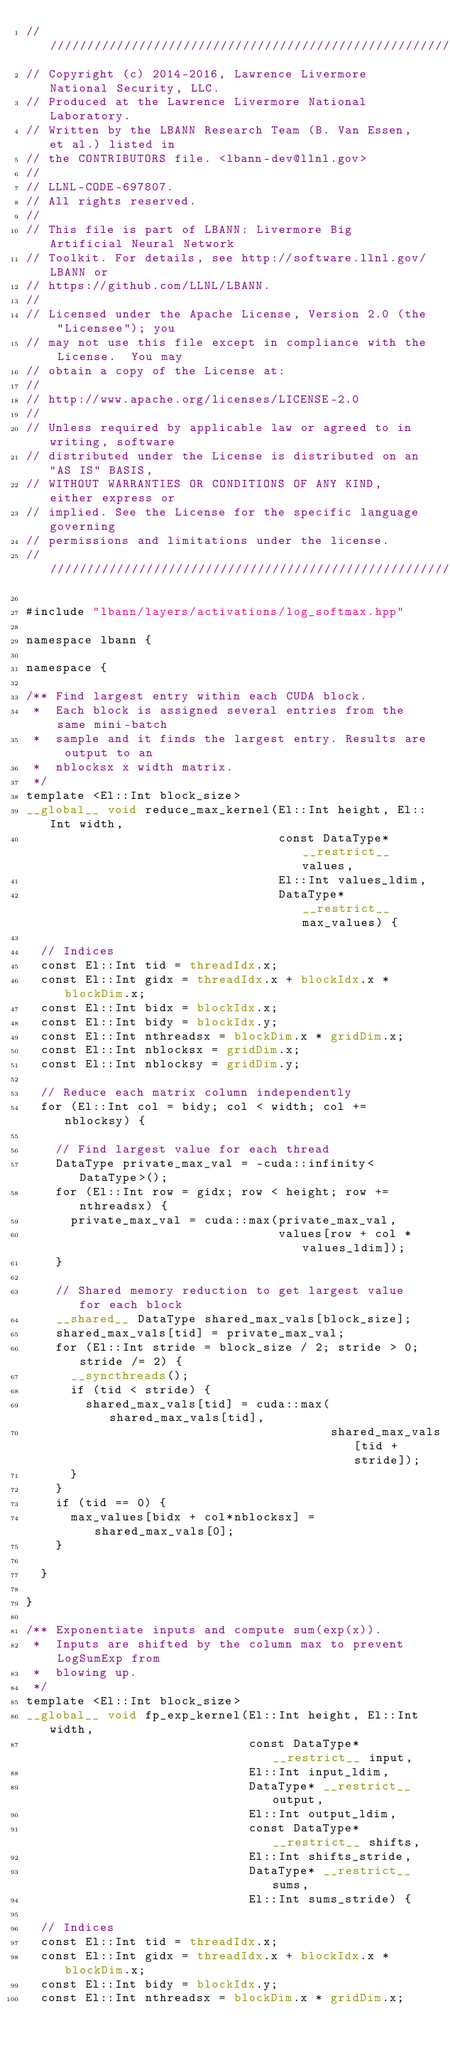<code> <loc_0><loc_0><loc_500><loc_500><_Cuda_>////////////////////////////////////////////////////////////////////////////////
// Copyright (c) 2014-2016, Lawrence Livermore National Security, LLC.
// Produced at the Lawrence Livermore National Laboratory.
// Written by the LBANN Research Team (B. Van Essen, et al.) listed in
// the CONTRIBUTORS file. <lbann-dev@llnl.gov>
//
// LLNL-CODE-697807.
// All rights reserved.
//
// This file is part of LBANN: Livermore Big Artificial Neural Network
// Toolkit. For details, see http://software.llnl.gov/LBANN or
// https://github.com/LLNL/LBANN.
//
// Licensed under the Apache License, Version 2.0 (the "Licensee"); you
// may not use this file except in compliance with the License.  You may
// obtain a copy of the License at:
//
// http://www.apache.org/licenses/LICENSE-2.0
//
// Unless required by applicable law or agreed to in writing, software
// distributed under the License is distributed on an "AS IS" BASIS,
// WITHOUT WARRANTIES OR CONDITIONS OF ANY KIND, either express or
// implied. See the License for the specific language governing
// permissions and limitations under the license.
////////////////////////////////////////////////////////////////////////////////

#include "lbann/layers/activations/log_softmax.hpp"

namespace lbann {

namespace {

/** Find largest entry within each CUDA block.
 *  Each block is assigned several entries from the same mini-batch
 *  sample and it finds the largest entry. Results are output to an
 *  nblocksx x width matrix.
 */
template <El::Int block_size>
__global__ void reduce_max_kernel(El::Int height, El::Int width,
                                  const DataType* __restrict__ values,
                                  El::Int values_ldim,
                                  DataType* __restrict__ max_values) {

  // Indices
  const El::Int tid = threadIdx.x;
  const El::Int gidx = threadIdx.x + blockIdx.x * blockDim.x;
  const El::Int bidx = blockIdx.x;
  const El::Int bidy = blockIdx.y;
  const El::Int nthreadsx = blockDim.x * gridDim.x;
  const El::Int nblocksx = gridDim.x;
  const El::Int nblocksy = gridDim.y;

  // Reduce each matrix column independently
  for (El::Int col = bidy; col < width; col += nblocksy) {

    // Find largest value for each thread
    DataType private_max_val = -cuda::infinity<DataType>();
    for (El::Int row = gidx; row < height; row += nthreadsx) {
      private_max_val = cuda::max(private_max_val,
                                  values[row + col * values_ldim]);
    }

    // Shared memory reduction to get largest value for each block
    __shared__ DataType shared_max_vals[block_size];
    shared_max_vals[tid] = private_max_val;
    for (El::Int stride = block_size / 2; stride > 0; stride /= 2) {
      __syncthreads();
      if (tid < stride) {
        shared_max_vals[tid] = cuda::max(shared_max_vals[tid],
                                         shared_max_vals[tid + stride]);
      }
    }
    if (tid == 0) {
      max_values[bidx + col*nblocksx] = shared_max_vals[0];
    }

  }

}

/** Exponentiate inputs and compute sum(exp(x)).
 *  Inputs are shifted by the column max to prevent LogSumExp from
 *  blowing up.
 */
template <El::Int block_size>
__global__ void fp_exp_kernel(El::Int height, El::Int width,
                              const DataType* __restrict__ input,
                              El::Int input_ldim,
                              DataType* __restrict__ output,
                              El::Int output_ldim,
                              const DataType* __restrict__ shifts,
                              El::Int shifts_stride,
                              DataType* __restrict__ sums,
                              El::Int sums_stride) {

  // Indices
  const El::Int tid = threadIdx.x;
  const El::Int gidx = threadIdx.x + blockIdx.x * blockDim.x;
  const El::Int bidy = blockIdx.y;
  const El::Int nthreadsx = blockDim.x * gridDim.x;</code> 